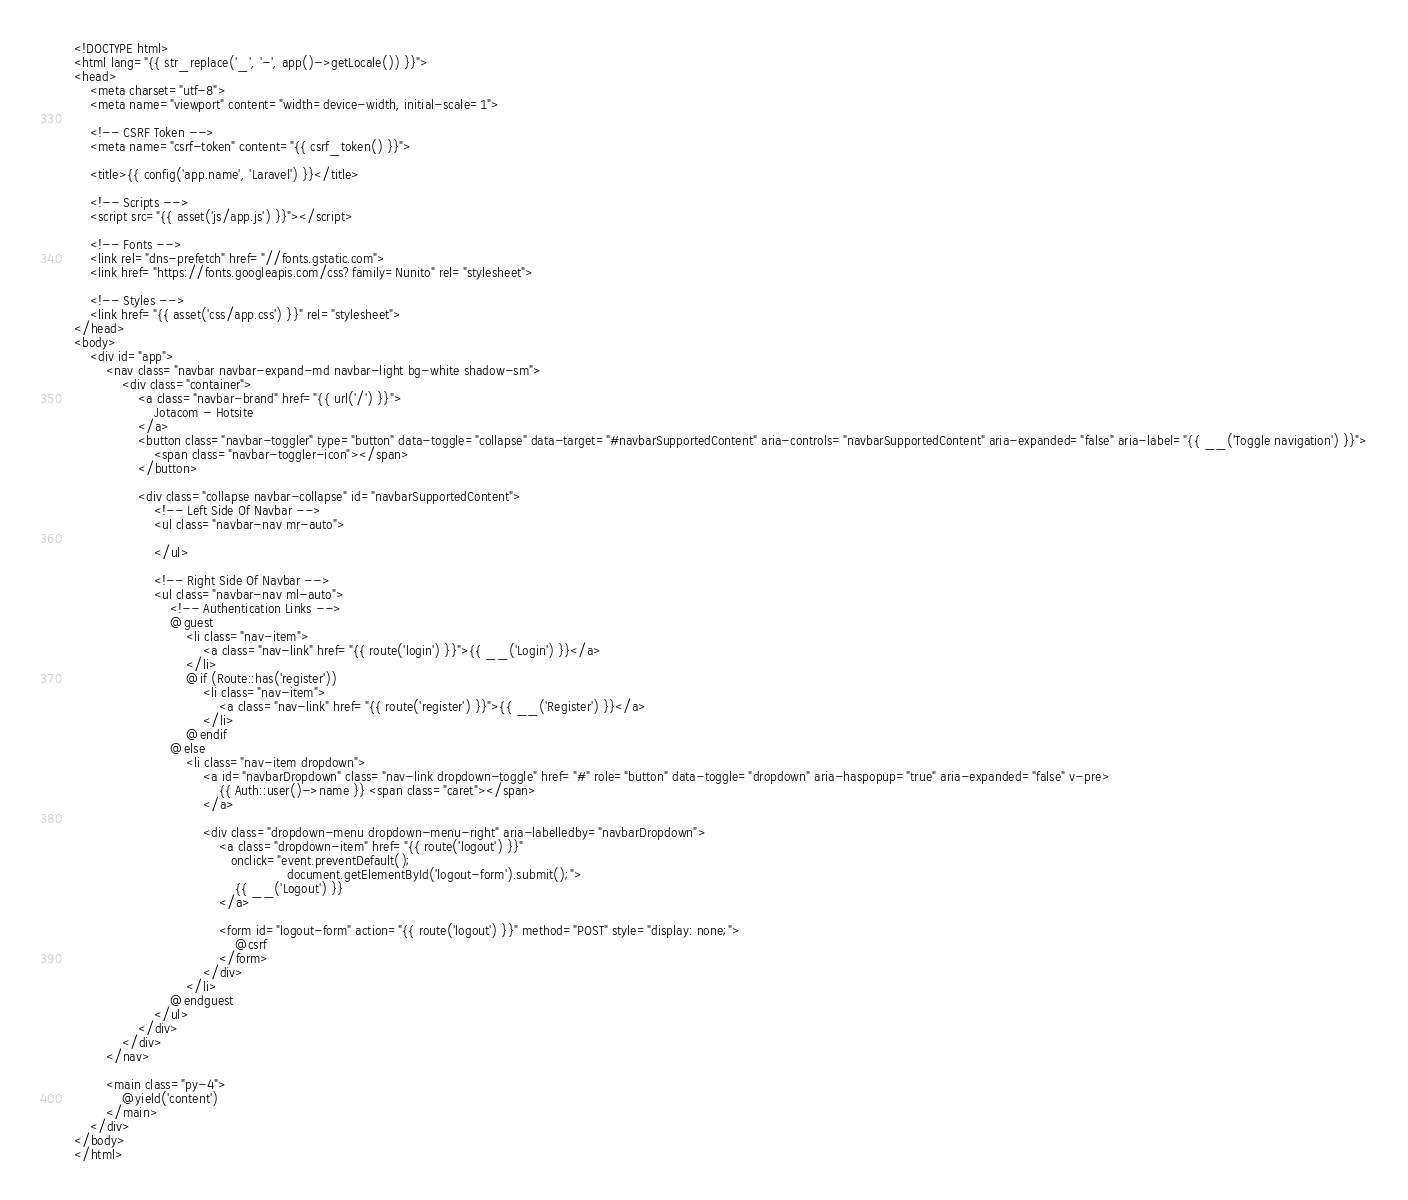<code> <loc_0><loc_0><loc_500><loc_500><_PHP_><!DOCTYPE html>
<html lang="{{ str_replace('_', '-', app()->getLocale()) }}">
<head>
    <meta charset="utf-8">
    <meta name="viewport" content="width=device-width, initial-scale=1">

    <!-- CSRF Token -->
    <meta name="csrf-token" content="{{ csrf_token() }}">

    <title>{{ config('app.name', 'Laravel') }}</title>

    <!-- Scripts -->
    <script src="{{ asset('js/app.js') }}"></script>

    <!-- Fonts -->
    <link rel="dns-prefetch" href="//fonts.gstatic.com">
    <link href="https://fonts.googleapis.com/css?family=Nunito" rel="stylesheet">

    <!-- Styles -->
    <link href="{{ asset('css/app.css') }}" rel="stylesheet">
</head>
<body>
    <div id="app">
        <nav class="navbar navbar-expand-md navbar-light bg-white shadow-sm">
            <div class="container">
                <a class="navbar-brand" href="{{ url('/') }}">
                    Jotacom - Hotsite
                </a>
                <button class="navbar-toggler" type="button" data-toggle="collapse" data-target="#navbarSupportedContent" aria-controls="navbarSupportedContent" aria-expanded="false" aria-label="{{ __('Toggle navigation') }}">
                    <span class="navbar-toggler-icon"></span>
                </button>

                <div class="collapse navbar-collapse" id="navbarSupportedContent">
                    <!-- Left Side Of Navbar -->
                    <ul class="navbar-nav mr-auto">

                    </ul>

                    <!-- Right Side Of Navbar -->
                    <ul class="navbar-nav ml-auto">
                        <!-- Authentication Links -->
                        @guest
                            <li class="nav-item">
                                <a class="nav-link" href="{{ route('login') }}">{{ __('Login') }}</a>
                            </li>
                            @if (Route::has('register'))
                                <li class="nav-item">
                                    <a class="nav-link" href="{{ route('register') }}">{{ __('Register') }}</a>
                                </li>
                            @endif
                        @else
                            <li class="nav-item dropdown">
                                <a id="navbarDropdown" class="nav-link dropdown-toggle" href="#" role="button" data-toggle="dropdown" aria-haspopup="true" aria-expanded="false" v-pre>
                                    {{ Auth::user()->name }} <span class="caret"></span>
                                </a>

                                <div class="dropdown-menu dropdown-menu-right" aria-labelledby="navbarDropdown">
                                    <a class="dropdown-item" href="{{ route('logout') }}"
                                       onclick="event.preventDefault();
                                                     document.getElementById('logout-form').submit();">
                                        {{ __('Logout') }}
                                    </a>

                                    <form id="logout-form" action="{{ route('logout') }}" method="POST" style="display: none;">
                                        @csrf
                                    </form>
                                </div>
                            </li>
                        @endguest
                    </ul>
                </div>
            </div>
        </nav>

        <main class="py-4">
            @yield('content')
        </main>
    </div>
</body>
</html>
</code> 